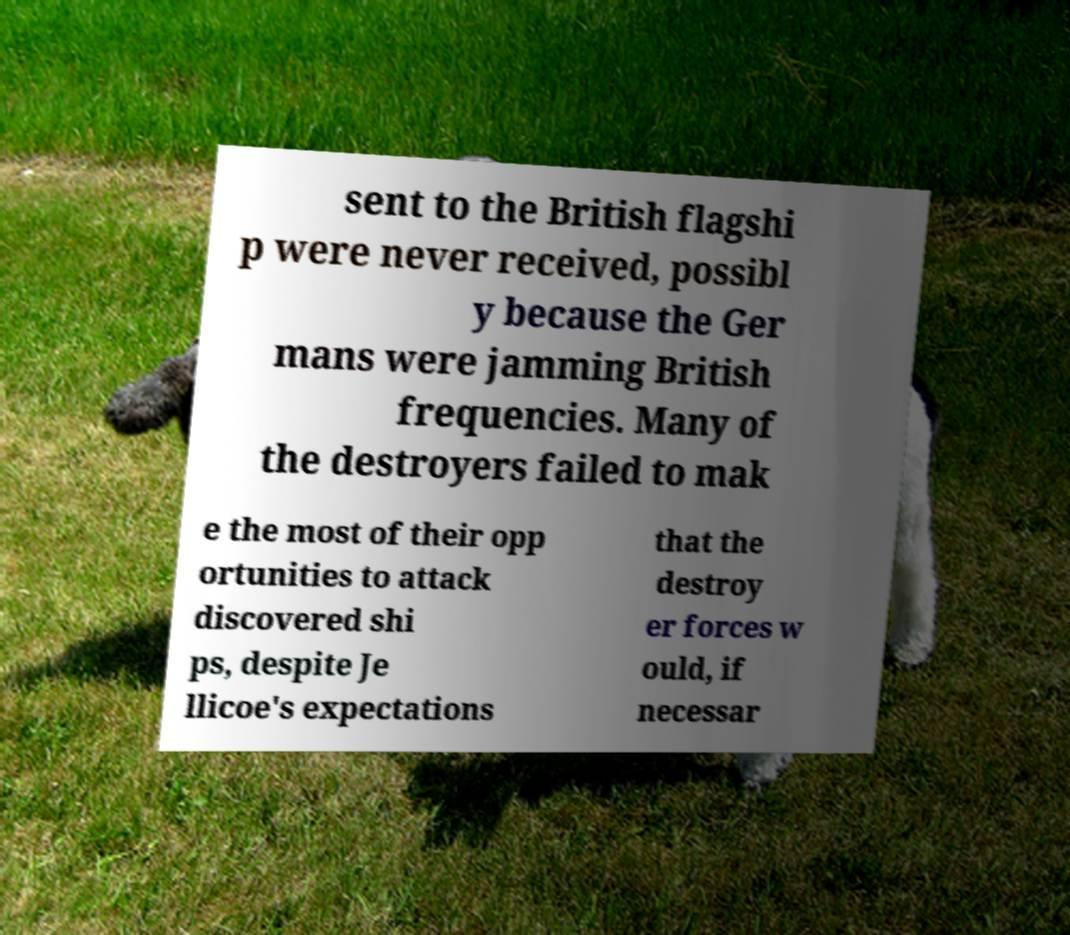Please identify and transcribe the text found in this image. sent to the British flagshi p were never received, possibl y because the Ger mans were jamming British frequencies. Many of the destroyers failed to mak e the most of their opp ortunities to attack discovered shi ps, despite Je llicoe's expectations that the destroy er forces w ould, if necessar 